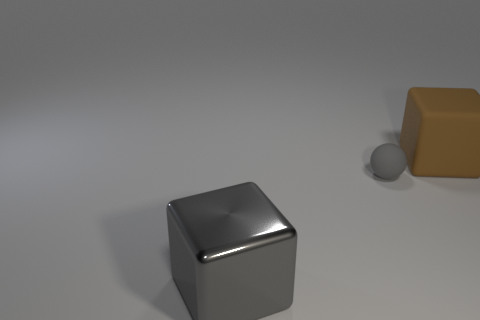There is a gray thing that is the same size as the brown block; what is it made of?
Make the answer very short. Metal. There is a cube that is in front of the brown cube; is it the same size as the rubber object in front of the big brown cube?
Keep it short and to the point. No. How big is the rubber thing left of the matte object that is on the right side of the small object?
Keep it short and to the point. Small. There is a thing that is behind the shiny cube and left of the large brown thing; what material is it made of?
Offer a very short reply. Rubber. What is the color of the small ball?
Offer a very short reply. Gray. Are there any other things that have the same material as the large gray cube?
Give a very brief answer. No. The big thing that is in front of the brown block has what shape?
Make the answer very short. Cube. Is there a tiny matte thing behind the big object that is on the right side of the gray object that is behind the metallic object?
Ensure brevity in your answer.  No. Are there any other things that have the same shape as the small object?
Provide a succinct answer. No. Is there a large brown matte thing?
Your answer should be compact. Yes. 